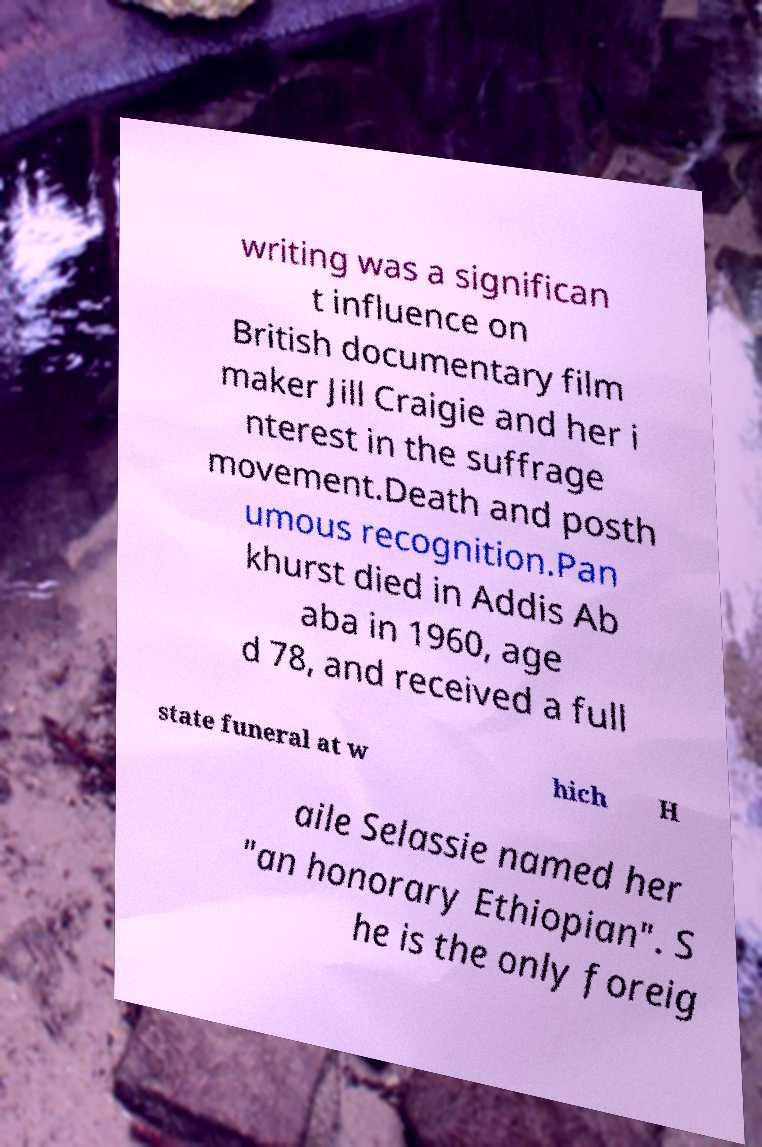What messages or text are displayed in this image? I need them in a readable, typed format. writing was a significan t influence on British documentary film maker Jill Craigie and her i nterest in the suffrage movement.Death and posth umous recognition.Pan khurst died in Addis Ab aba in 1960, age d 78, and received a full state funeral at w hich H aile Selassie named her "an honorary Ethiopian". S he is the only foreig 